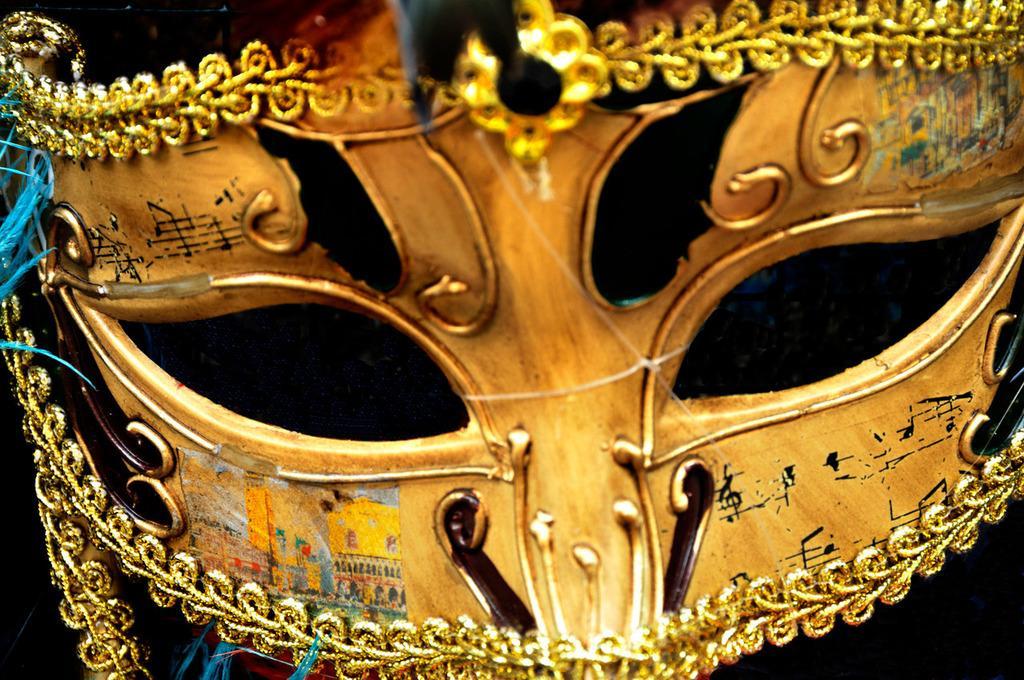Describe this image in one or two sentences. This is an eye mask. And this is in golden and black color. On the border where are golden lace. In the back it is dark. 